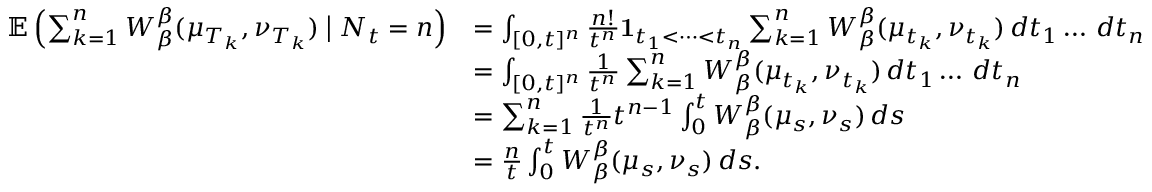Convert formula to latex. <formula><loc_0><loc_0><loc_500><loc_500>\begin{array} { r l } { \mathbb { E } \left ( \sum _ { k = 1 } ^ { n } W _ { \beta } ^ { \beta } ( \mu _ { T _ { k } } , \nu _ { T _ { k } } ) \Big | N _ { t } = n \right ) } & { = \int _ { [ 0 , t ] ^ { n } } \frac { n ! } { t ^ { n } } 1 _ { t _ { 1 } < \dots < t _ { n } } \sum _ { k = 1 } ^ { n } W _ { \beta } ^ { \beta } ( \mu _ { t _ { k } } , \nu _ { t _ { k } } ) \, d t _ { 1 } \dots \, d t _ { n } } \\ & { = \int _ { [ 0 , t ] ^ { n } } \frac { 1 } { t ^ { n } } \sum _ { k = 1 } ^ { n } W _ { \beta } ^ { \beta } ( \mu _ { t _ { k } } , \nu _ { t _ { k } } ) \, d t _ { 1 } \dots \, d t _ { n } } \\ & { = \sum _ { k = 1 } ^ { n } \frac { 1 } { t ^ { n } } t ^ { n - 1 } \int _ { 0 } ^ { t } W _ { \beta } ^ { \beta } ( \mu _ { s } , \nu _ { s } ) \, d s } \\ & { = \frac { n } { t } \int _ { 0 } ^ { t } W _ { \beta } ^ { \beta } ( \mu _ { s } , \nu _ { s } ) \, d s . } \end{array}</formula> 